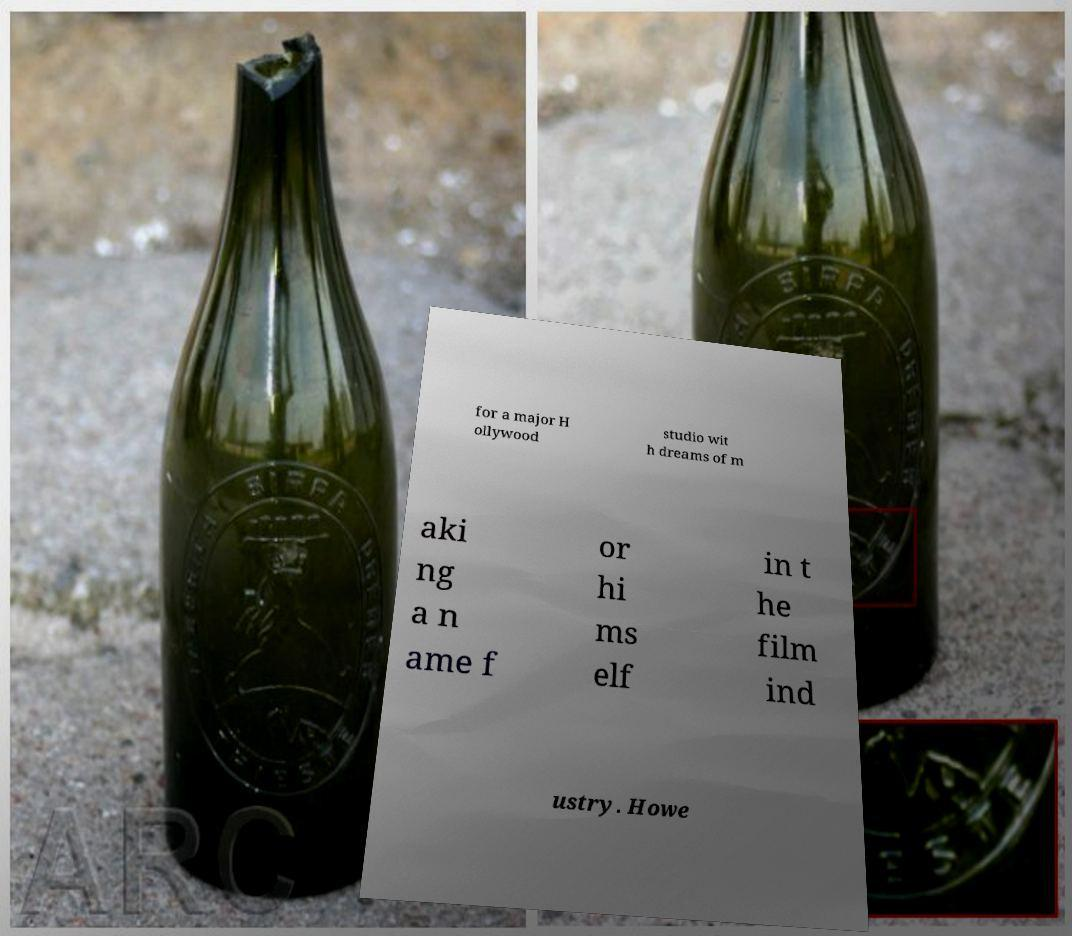For documentation purposes, I need the text within this image transcribed. Could you provide that? for a major H ollywood studio wit h dreams of m aki ng a n ame f or hi ms elf in t he film ind ustry. Howe 